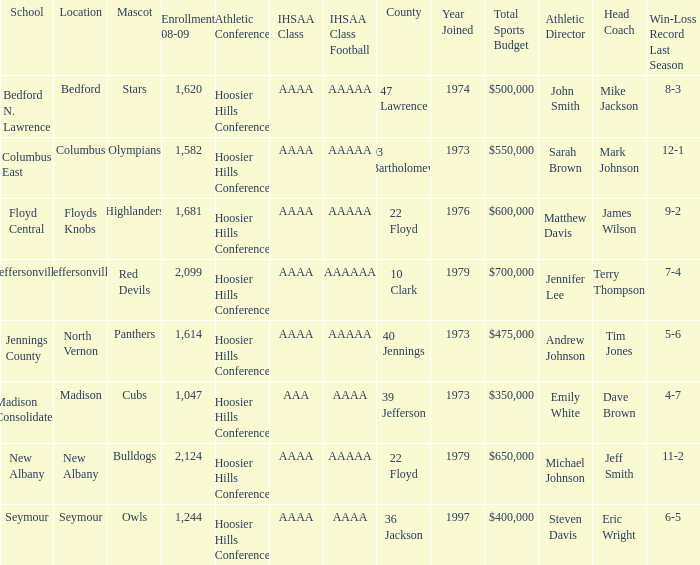What school is in 36 Jackson? Seymour. 